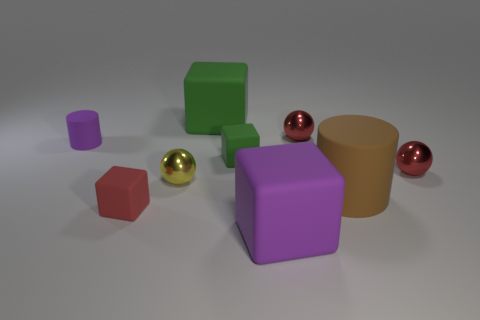What shape is the object that is to the left of the tiny green thing and in front of the brown object?
Offer a very short reply. Cube. The metallic object that is on the left side of the red metallic sphere to the left of the brown cylinder is what shape?
Make the answer very short. Sphere. Does the brown rubber thing have the same shape as the tiny purple rubber thing?
Offer a terse response. Yes. What number of objects are to the left of the matte cylinder on the right side of the small metallic ball that is behind the tiny cylinder?
Your response must be concise. 7. There is a tiny red thing that is the same material as the big green thing; what is its shape?
Your answer should be very brief. Cube. What is the material of the sphere left of the large rubber object that is behind the metallic object left of the purple rubber cube?
Offer a very short reply. Metal. How many objects are big matte objects that are in front of the small matte cylinder or green rubber things?
Your answer should be compact. 4. What number of other objects are the same shape as the red matte object?
Ensure brevity in your answer.  3. Is the number of tiny matte cubes that are behind the brown cylinder greater than the number of big cyan matte things?
Your answer should be very brief. Yes. The red thing that is the same shape as the small green object is what size?
Keep it short and to the point. Small. 